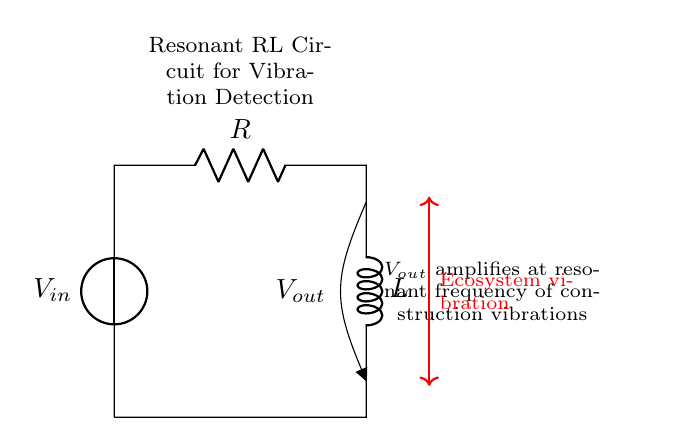What components are in the circuit? The circuit contains a voltage source, a resistor, and an inductor. Each component is represented in the diagram, which labels them clearly.
Answer: voltage source, resistor, inductor What does Vout represent in this circuit? Vout denotes the output voltage measured across the inductor. This is indicated by the label in the circuit diagram connected to the inductor.
Answer: output voltage What is the role of the inductor in this circuit? The inductor stores energy in the form of a magnetic field and allows current to change at a certain rate, which is crucial for achieving resonance. This is inferred from the position of the inductor in series with the resistor and the overall function of the circuit.
Answer: stores energy At what frequency does Vout amplify vibrations? Vout amplifies at the resonant frequency which is determined by the values of R and L in the circuit. The resonance occurs when the inductive reactance equals the resistance, typically calculated using the formula for resonant frequency in an RL circuit.
Answer: resonant frequency How can this circuit be used in ecosystems? This circuit detects vibrations caused by construction activities, helping to monitor changes in sensitive ecosystems. This is interpreted from the labels and annotations provided in the circuit diagram indicating that it measures ecosystem vibrations.
Answer: vibration detection What is the significance of the resistor in the circuit? The resistor limits current flow and dissipates energy as heat, affecting the circuit's response at specific frequencies. Its function as a damping element in a resonant circuit is inferred from its placement and role in controlling resonance behavior.
Answer: limits current How is the input and output voltage compared in terms of resonance? The input voltage provides the energy to the circuit, and the output voltage indicates the amplified response at the resonant frequency, showing a specific relationship determined by the circuit's parameters. This relationship is understood through examining the function of input and output in resonance conditions.
Answer: input and output voltage relationship 